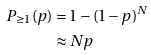Convert formula to latex. <formula><loc_0><loc_0><loc_500><loc_500>P _ { \geq 1 } ( p ) & = 1 - ( 1 - p ) ^ { N } \\ & \approx N p</formula> 